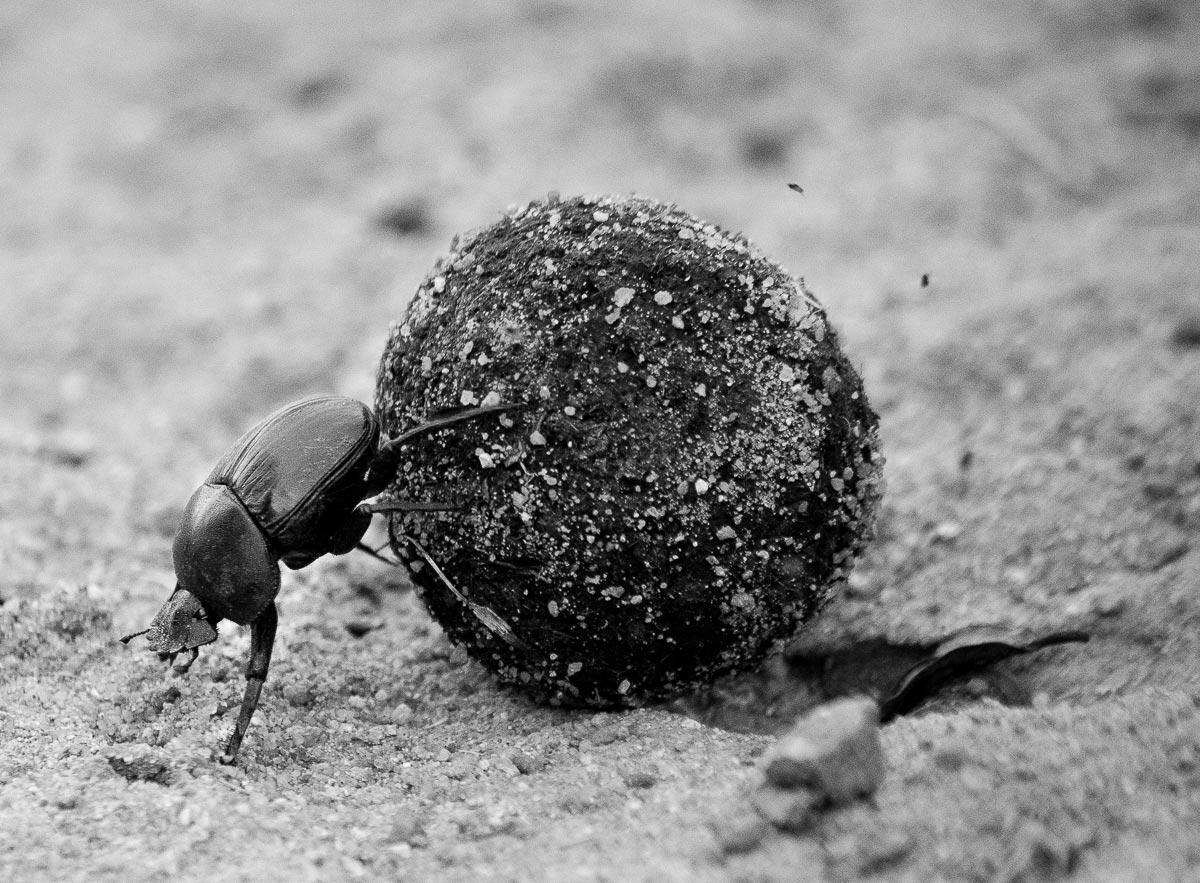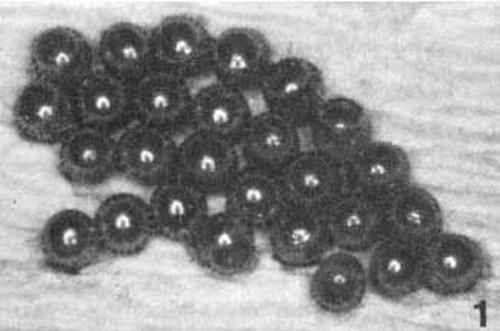The first image is the image on the left, the second image is the image on the right. For the images shown, is this caption "One image shows one beetle in contact with a round shape, and the other image includes a mass of small dark round things." true? Answer yes or no. Yes. The first image is the image on the left, the second image is the image on the right. Evaluate the accuracy of this statement regarding the images: "A beetle is in the 11 o'clock position on top of a dung ball.". Is it true? Answer yes or no. No. 